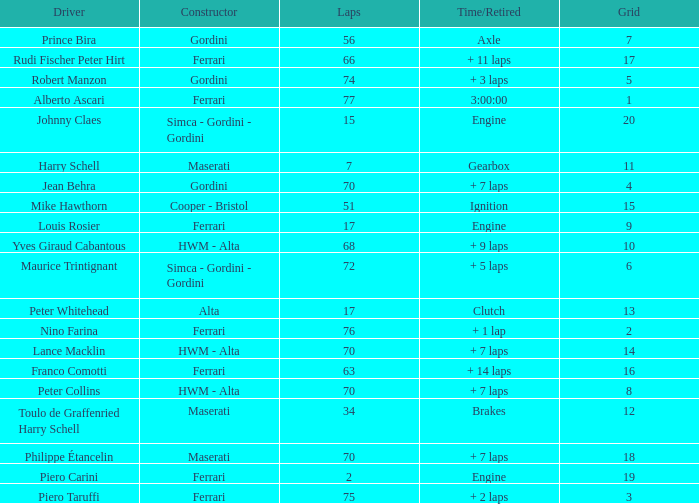Could you parse the entire table? {'header': ['Driver', 'Constructor', 'Laps', 'Time/Retired', 'Grid'], 'rows': [['Prince Bira', 'Gordini', '56', 'Axle', '7'], ['Rudi Fischer Peter Hirt', 'Ferrari', '66', '+ 11 laps', '17'], ['Robert Manzon', 'Gordini', '74', '+ 3 laps', '5'], ['Alberto Ascari', 'Ferrari', '77', '3:00:00', '1'], ['Johnny Claes', 'Simca - Gordini - Gordini', '15', 'Engine', '20'], ['Harry Schell', 'Maserati', '7', 'Gearbox', '11'], ['Jean Behra', 'Gordini', '70', '+ 7 laps', '4'], ['Mike Hawthorn', 'Cooper - Bristol', '51', 'Ignition', '15'], ['Louis Rosier', 'Ferrari', '17', 'Engine', '9'], ['Yves Giraud Cabantous', 'HWM - Alta', '68', '+ 9 laps', '10'], ['Maurice Trintignant', 'Simca - Gordini - Gordini', '72', '+ 5 laps', '6'], ['Peter Whitehead', 'Alta', '17', 'Clutch', '13'], ['Nino Farina', 'Ferrari', '76', '+ 1 lap', '2'], ['Lance Macklin', 'HWM - Alta', '70', '+ 7 laps', '14'], ['Franco Comotti', 'Ferrari', '63', '+ 14 laps', '16'], ['Peter Collins', 'HWM - Alta', '70', '+ 7 laps', '8'], ['Toulo de Graffenried Harry Schell', 'Maserati', '34', 'Brakes', '12'], ['Philippe Étancelin', 'Maserati', '70', '+ 7 laps', '18'], ['Piero Carini', 'Ferrari', '2', 'Engine', '19'], ['Piero Taruffi', 'Ferrari', '75', '+ 2 laps', '3']]} What is the high grid for ferrari's with 2 laps? 19.0. 